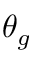Convert formula to latex. <formula><loc_0><loc_0><loc_500><loc_500>\theta _ { g }</formula> 